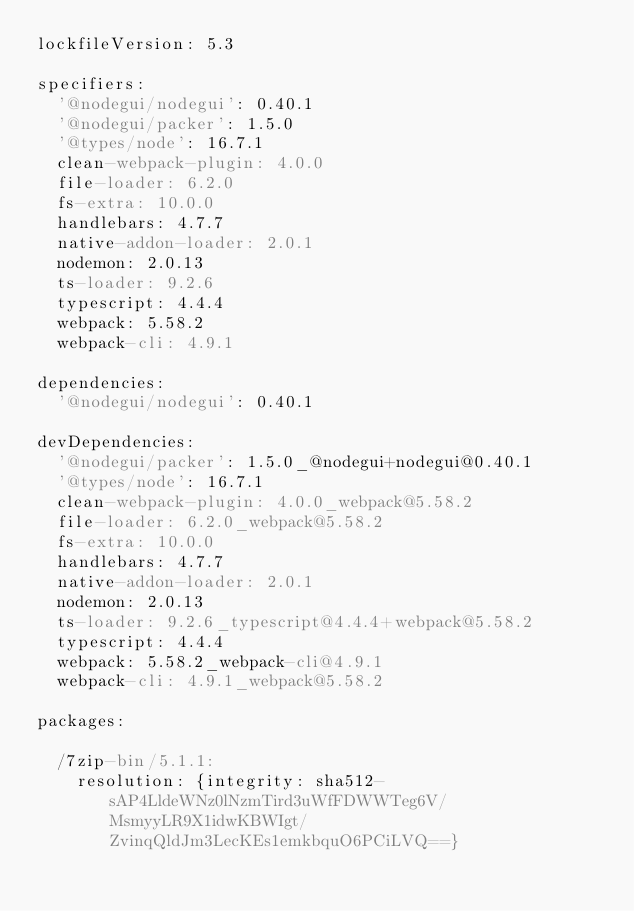Convert code to text. <code><loc_0><loc_0><loc_500><loc_500><_YAML_>lockfileVersion: 5.3

specifiers:
  '@nodegui/nodegui': 0.40.1
  '@nodegui/packer': 1.5.0
  '@types/node': 16.7.1
  clean-webpack-plugin: 4.0.0
  file-loader: 6.2.0
  fs-extra: 10.0.0
  handlebars: 4.7.7
  native-addon-loader: 2.0.1
  nodemon: 2.0.13
  ts-loader: 9.2.6
  typescript: 4.4.4
  webpack: 5.58.2
  webpack-cli: 4.9.1

dependencies:
  '@nodegui/nodegui': 0.40.1

devDependencies:
  '@nodegui/packer': 1.5.0_@nodegui+nodegui@0.40.1
  '@types/node': 16.7.1
  clean-webpack-plugin: 4.0.0_webpack@5.58.2
  file-loader: 6.2.0_webpack@5.58.2
  fs-extra: 10.0.0
  handlebars: 4.7.7
  native-addon-loader: 2.0.1
  nodemon: 2.0.13
  ts-loader: 9.2.6_typescript@4.4.4+webpack@5.58.2
  typescript: 4.4.4
  webpack: 5.58.2_webpack-cli@4.9.1
  webpack-cli: 4.9.1_webpack@5.58.2

packages:

  /7zip-bin/5.1.1:
    resolution: {integrity: sha512-sAP4LldeWNz0lNzmTird3uWfFDWWTeg6V/MsmyyLR9X1idwKBWIgt/ZvinqQldJm3LecKEs1emkbquO6PCiLVQ==}
</code> 